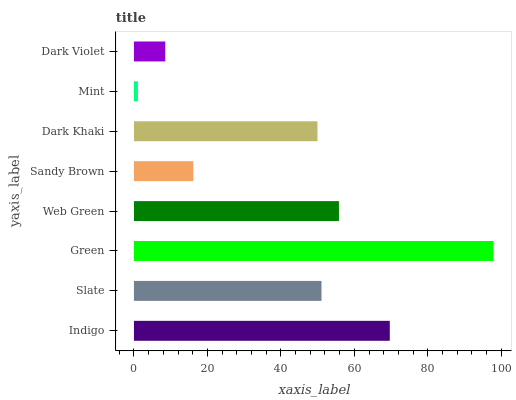Is Mint the minimum?
Answer yes or no. Yes. Is Green the maximum?
Answer yes or no. Yes. Is Slate the minimum?
Answer yes or no. No. Is Slate the maximum?
Answer yes or no. No. Is Indigo greater than Slate?
Answer yes or no. Yes. Is Slate less than Indigo?
Answer yes or no. Yes. Is Slate greater than Indigo?
Answer yes or no. No. Is Indigo less than Slate?
Answer yes or no. No. Is Slate the high median?
Answer yes or no. Yes. Is Dark Khaki the low median?
Answer yes or no. Yes. Is Green the high median?
Answer yes or no. No. Is Slate the low median?
Answer yes or no. No. 